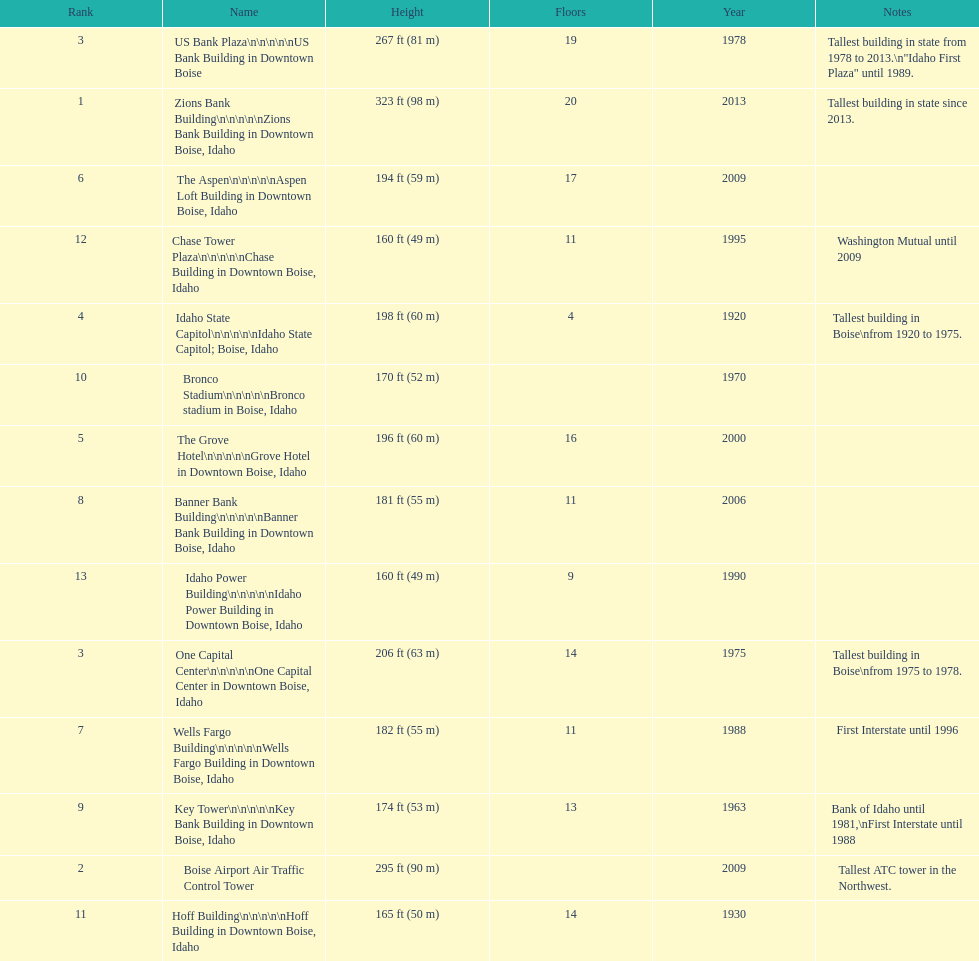How many floors does the tallest building have? 20. 